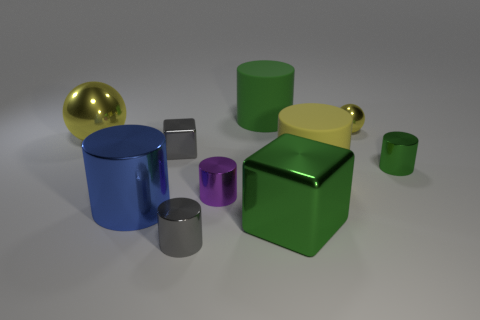What shape is the big yellow thing to the right of the gray object that is in front of the gray metal cube?
Your response must be concise. Cylinder. What is the size of the block in front of the blue cylinder?
Ensure brevity in your answer.  Large. Do the blue thing and the large yellow cylinder have the same material?
Offer a terse response. No. The purple thing that is the same material as the small yellow object is what shape?
Give a very brief answer. Cylinder. Is there any other thing of the same color as the large metallic cylinder?
Make the answer very short. No. The metallic ball that is on the left side of the small yellow metallic thing is what color?
Offer a terse response. Yellow. Do the large matte object that is behind the big yellow sphere and the big block have the same color?
Your answer should be compact. Yes. There is a small gray object that is the same shape as the green rubber object; what is its material?
Your answer should be very brief. Metal. How many matte cylinders are the same size as the yellow matte object?
Ensure brevity in your answer.  1. What is the shape of the big yellow rubber object?
Provide a short and direct response. Cylinder. 